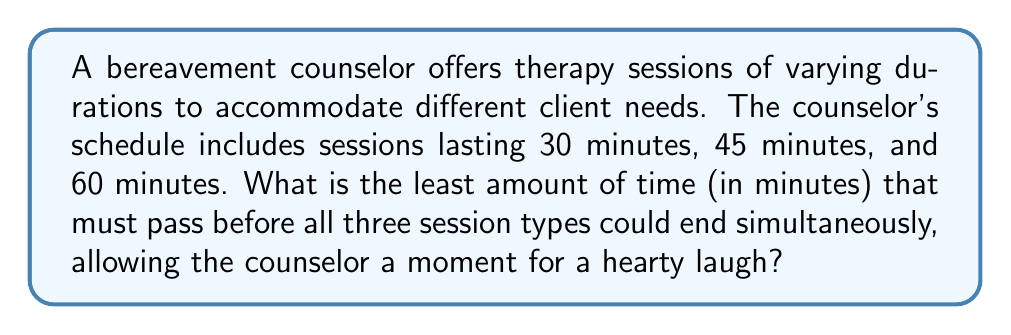Show me your answer to this math problem. To solve this problem, we need to find the least common multiple (LCM) of 30, 45, and 60 minutes.

Step 1: Prime factorization of the given numbers
$30 = 2 \times 3 \times 5$
$45 = 3^2 \times 5$
$60 = 2^2 \times 3 \times 5$

Step 2: Identify the highest power of each prime factor
$2^2$ (from 60)
$3^2$ (from 45)
$5^1$ (from all numbers)

Step 3: Calculate the LCM by multiplying these highest powers
$$LCM = 2^2 \times 3^2 \times 5 = 4 \times 9 \times 5 = 180$$

Therefore, the least amount of time that must pass before all three session types could end simultaneously is 180 minutes.
Answer: 180 minutes 